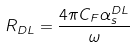Convert formula to latex. <formula><loc_0><loc_0><loc_500><loc_500>R _ { D L } = \frac { 4 \pi C _ { F } \alpha _ { s } ^ { D L } } { \omega }</formula> 